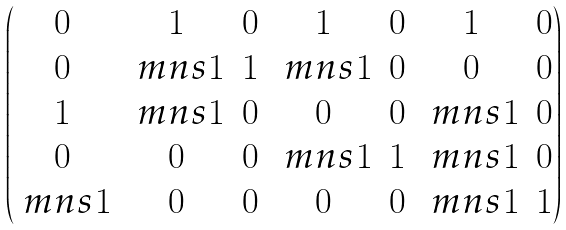<formula> <loc_0><loc_0><loc_500><loc_500>\begin{pmatrix} 0 & 1 & 0 & 1 & 0 & 1 & 0 \\ 0 & \ m n s 1 & 1 & \ m n s 1 & 0 & 0 & 0 \\ 1 & \ m n s 1 & 0 & 0 & 0 & \ m n s 1 & 0 \\ 0 & 0 & 0 & \ m n s 1 & 1 & \ m n s 1 & 0 \\ \ m n s 1 & 0 & 0 & 0 & 0 & \ m n s 1 & 1 \\ \end{pmatrix}</formula> 